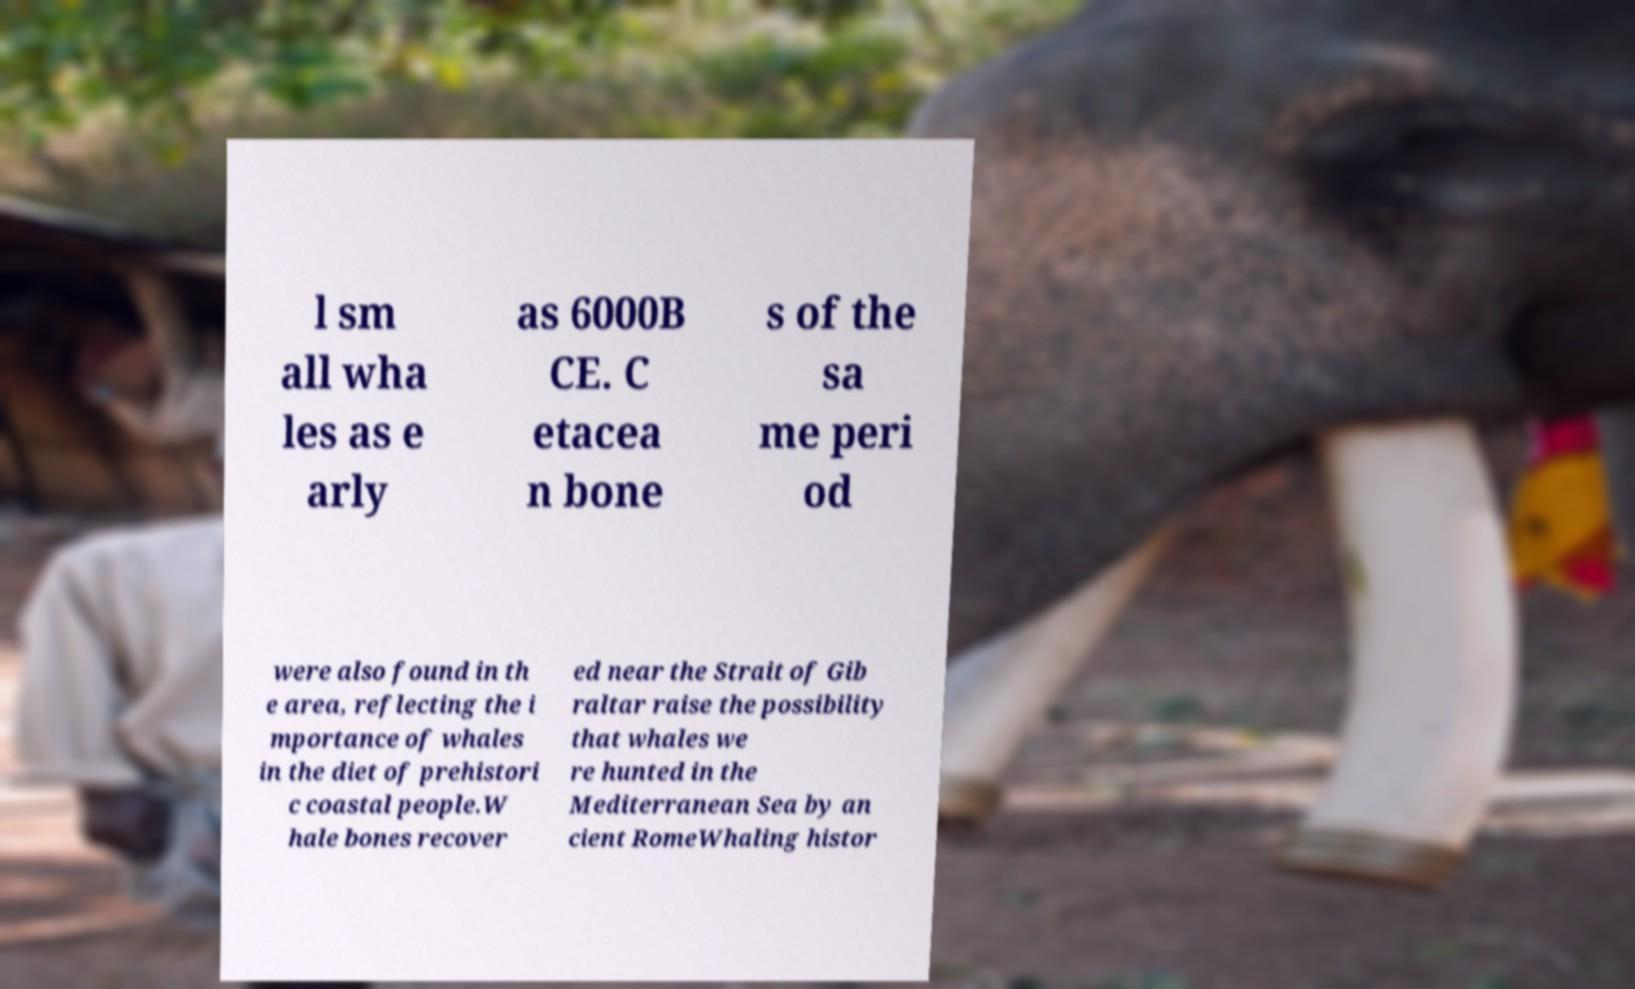Can you accurately transcribe the text from the provided image for me? l sm all wha les as e arly as 6000B CE. C etacea n bone s of the sa me peri od were also found in th e area, reflecting the i mportance of whales in the diet of prehistori c coastal people.W hale bones recover ed near the Strait of Gib raltar raise the possibility that whales we re hunted in the Mediterranean Sea by an cient RomeWhaling histor 